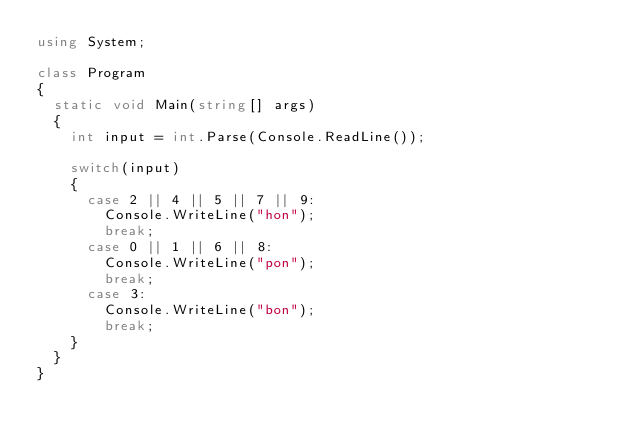<code> <loc_0><loc_0><loc_500><loc_500><_C#_>using System;

class Program
{
  static void Main(string[] args)
  {
    int input = int.Parse(Console.ReadLine());
    
    switch(input)
    {
      case 2 || 4 || 5 || 7 || 9:
        Console.WriteLine("hon");
        break;
      case 0 || 1 || 6 || 8:
        Console.WriteLine("pon");
        break;
      case 3:
        Console.WriteLine("bon");
        break;
    }
  }
}</code> 